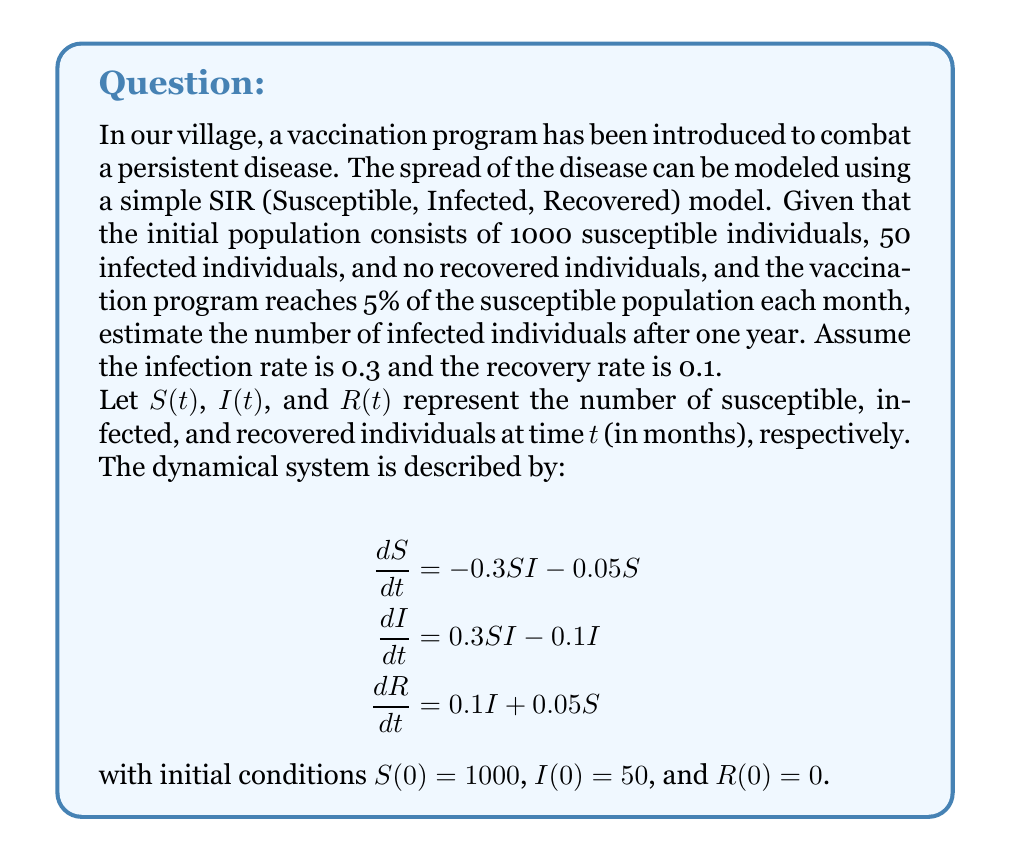Provide a solution to this math problem. To solve this problem, we'll use a numerical method called Euler's method to approximate the solution of the dynamical system. We'll use a time step of 1 month for 12 months.

Let's define our step size $h = 1$ month and the number of steps $n = 12$.

For each step $i$ from 0 to 11:

1. Calculate the rates of change:
   $$\begin{aligned}
   \frac{\Delta S}{\Delta t} &= -0.3S_iI_i - 0.05S_i \\
   \frac{\Delta I}{\Delta t} &= 0.3S_iI_i - 0.1I_i \\
   \frac{\Delta R}{\Delta t} &= 0.1I_i + 0.05S_i
   \end{aligned}$$

2. Update the values:
   $$\begin{aligned}
   S_{i+1} &= S_i + h \cdot \frac{\Delta S}{\Delta t} \\
   I_{i+1} &= I_i + h \cdot \frac{\Delta I}{\Delta t} \\
   R_{i+1} &= R_i + h \cdot \frac{\Delta R}{\Delta t}
   \end{aligned}$$

Let's perform the calculations:

Month 0: $S_0 = 1000$, $I_0 = 50$, $R_0 = 0$

Month 1:
$$\begin{aligned}
\frac{\Delta S}{\Delta t} &= -0.3 \cdot 1000 \cdot 50 - 0.05 \cdot 1000 = -15050 \\
\frac{\Delta I}{\Delta t} &= 0.3 \cdot 1000 \cdot 50 - 0.1 \cdot 50 = 14995 \\
\frac{\Delta R}{\Delta t} &= 0.1 \cdot 50 + 0.05 \cdot 1000 = 55
\end{aligned}$$

$$\begin{aligned}
S_1 &= 1000 + 1 \cdot (-15050) = -14050 \\
I_1 &= 50 + 1 \cdot 14995 = 15045 \\
R_1 &= 0 + 1 \cdot 55 = 55
\end{aligned}$$

We continue this process for the remaining months. After 12 iterations, we find:

$S_{12} \approx 0$ (negative values are treated as 0)
$I_{12} \approx 22$
$R_{12} \approx 1028$
Answer: Approximately 22 infected individuals after one year. 